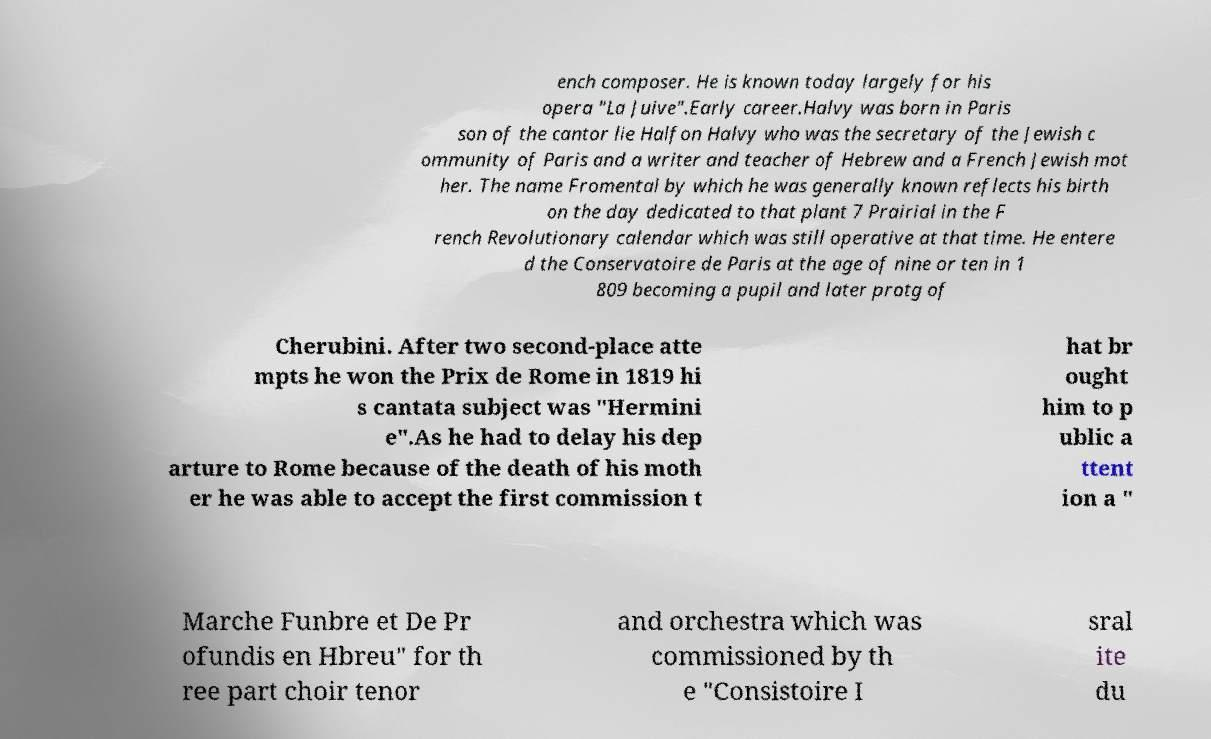Could you assist in decoding the text presented in this image and type it out clearly? ench composer. He is known today largely for his opera "La Juive".Early career.Halvy was born in Paris son of the cantor lie Halfon Halvy who was the secretary of the Jewish c ommunity of Paris and a writer and teacher of Hebrew and a French Jewish mot her. The name Fromental by which he was generally known reflects his birth on the day dedicated to that plant 7 Prairial in the F rench Revolutionary calendar which was still operative at that time. He entere d the Conservatoire de Paris at the age of nine or ten in 1 809 becoming a pupil and later protg of Cherubini. After two second-place atte mpts he won the Prix de Rome in 1819 hi s cantata subject was "Hermini e".As he had to delay his dep arture to Rome because of the death of his moth er he was able to accept the first commission t hat br ought him to p ublic a ttent ion a " Marche Funbre et De Pr ofundis en Hbreu" for th ree part choir tenor and orchestra which was commissioned by th e "Consistoire I sral ite du 